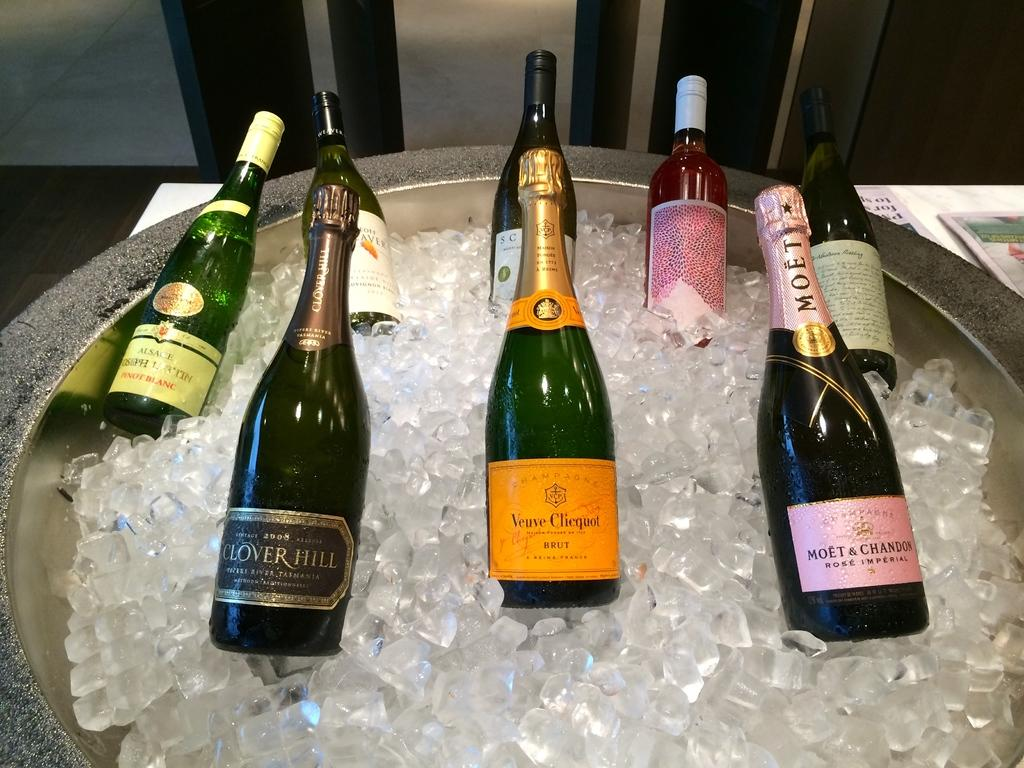What is unique about the ice cubes in the image? The ice cubes contain bottles in them. What else can be seen in the image besides the ice cubes? Papers are present in the image. What type of instrument is being played in the image? There is no instrument present in the image; it only features bottles in ice cubes and papers. 